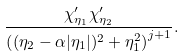<formula> <loc_0><loc_0><loc_500><loc_500>\frac { \chi _ { \eta _ { 1 } } ^ { \prime } \chi _ { \eta _ { 2 } } ^ { \prime } } { \left ( ( \eta _ { 2 } - \alpha | \eta _ { 1 } | ) ^ { 2 } + \eta _ { 1 } ^ { 2 } \right ) ^ { j + 1 } } .</formula> 